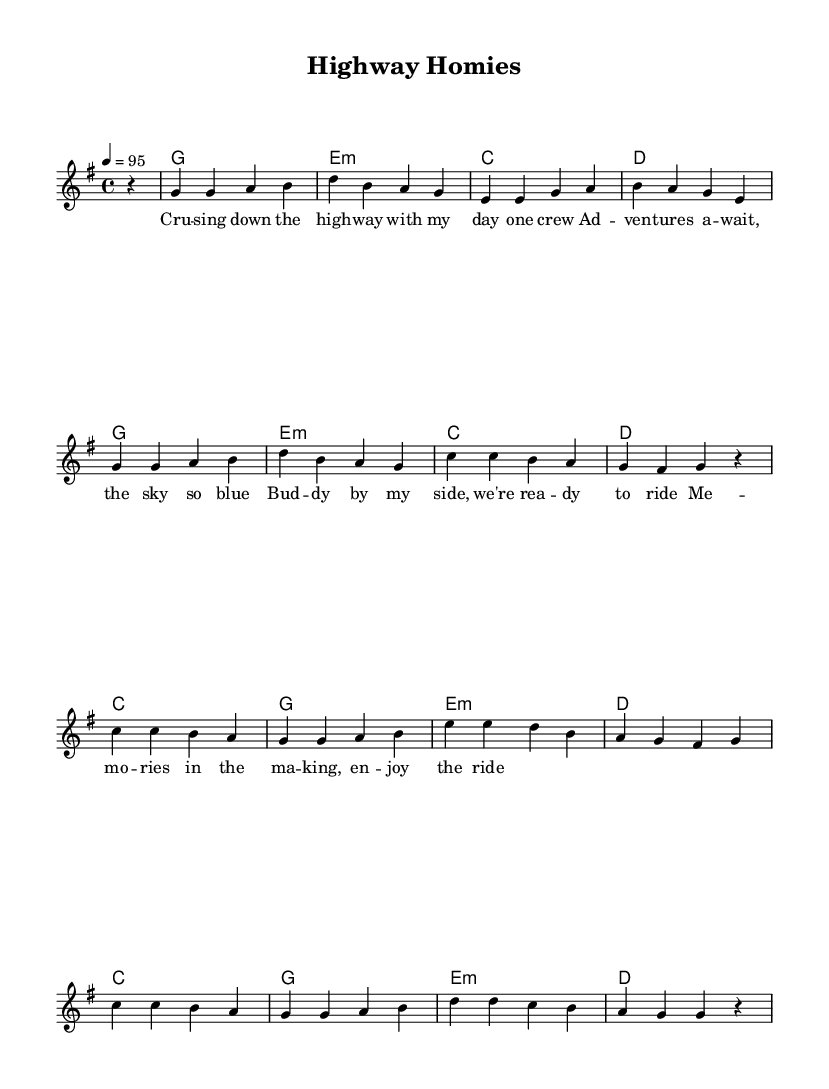What is the key signature of this music? The key signature is G major, which has one sharp. This can be determined by examining the key signature symbol at the beginning of the staff.
Answer: G major What is the time signature of this music? The time signature is 4/4, identified by the notation at the beginning of the score that indicates there are four beats in each measure.
Answer: 4/4 What is the tempo indicated in this piece? The tempo marking at the beginning states "4 = 95," which indicates that there are 95 beats per minute. This is the speed at which the music should be played.
Answer: 95 How many measures are in the chorus section? The chorus section consists of two repeated phrases, each having four measures, making a total of eight measures. By counting the measures in the written music, you can find the total.
Answer: 8 What mood does the rhythmic structure suggest for this song? The upbeat tempo combined with a lively melody and repetitive chord progressions suggests a fun, energetic mood suitable for a road trip with friends. This can be inferred from the drive in the rhythm and the themes presented in the lyrics.
Answer: Energetic What is the lyric theme of the song? The lyrics revolve around friendship, adventures, and experiencing the freedom of the open road with good company. This can be found by analyzing the content of the lyrics in relation to the title and overall style of the music.
Answer: Friendship and adventure What type of accompaniment is featured in the music? The music includes chord changes indicated above the staff, which suggests a harmonic accompaniment accompanying the melody, typical of hip hop music. This can be deduced from the chord progression alongside the vocal line.
Answer: Harmonic accompaniment 